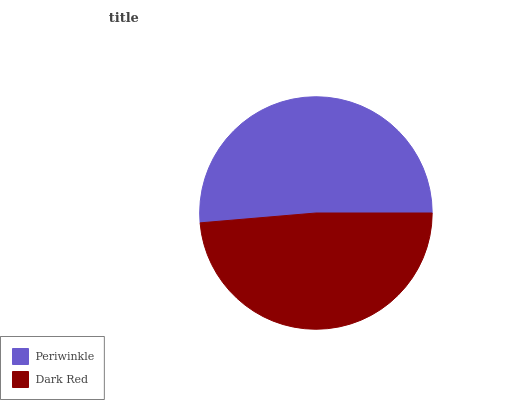Is Dark Red the minimum?
Answer yes or no. Yes. Is Periwinkle the maximum?
Answer yes or no. Yes. Is Dark Red the maximum?
Answer yes or no. No. Is Periwinkle greater than Dark Red?
Answer yes or no. Yes. Is Dark Red less than Periwinkle?
Answer yes or no. Yes. Is Dark Red greater than Periwinkle?
Answer yes or no. No. Is Periwinkle less than Dark Red?
Answer yes or no. No. Is Periwinkle the high median?
Answer yes or no. Yes. Is Dark Red the low median?
Answer yes or no. Yes. Is Dark Red the high median?
Answer yes or no. No. Is Periwinkle the low median?
Answer yes or no. No. 